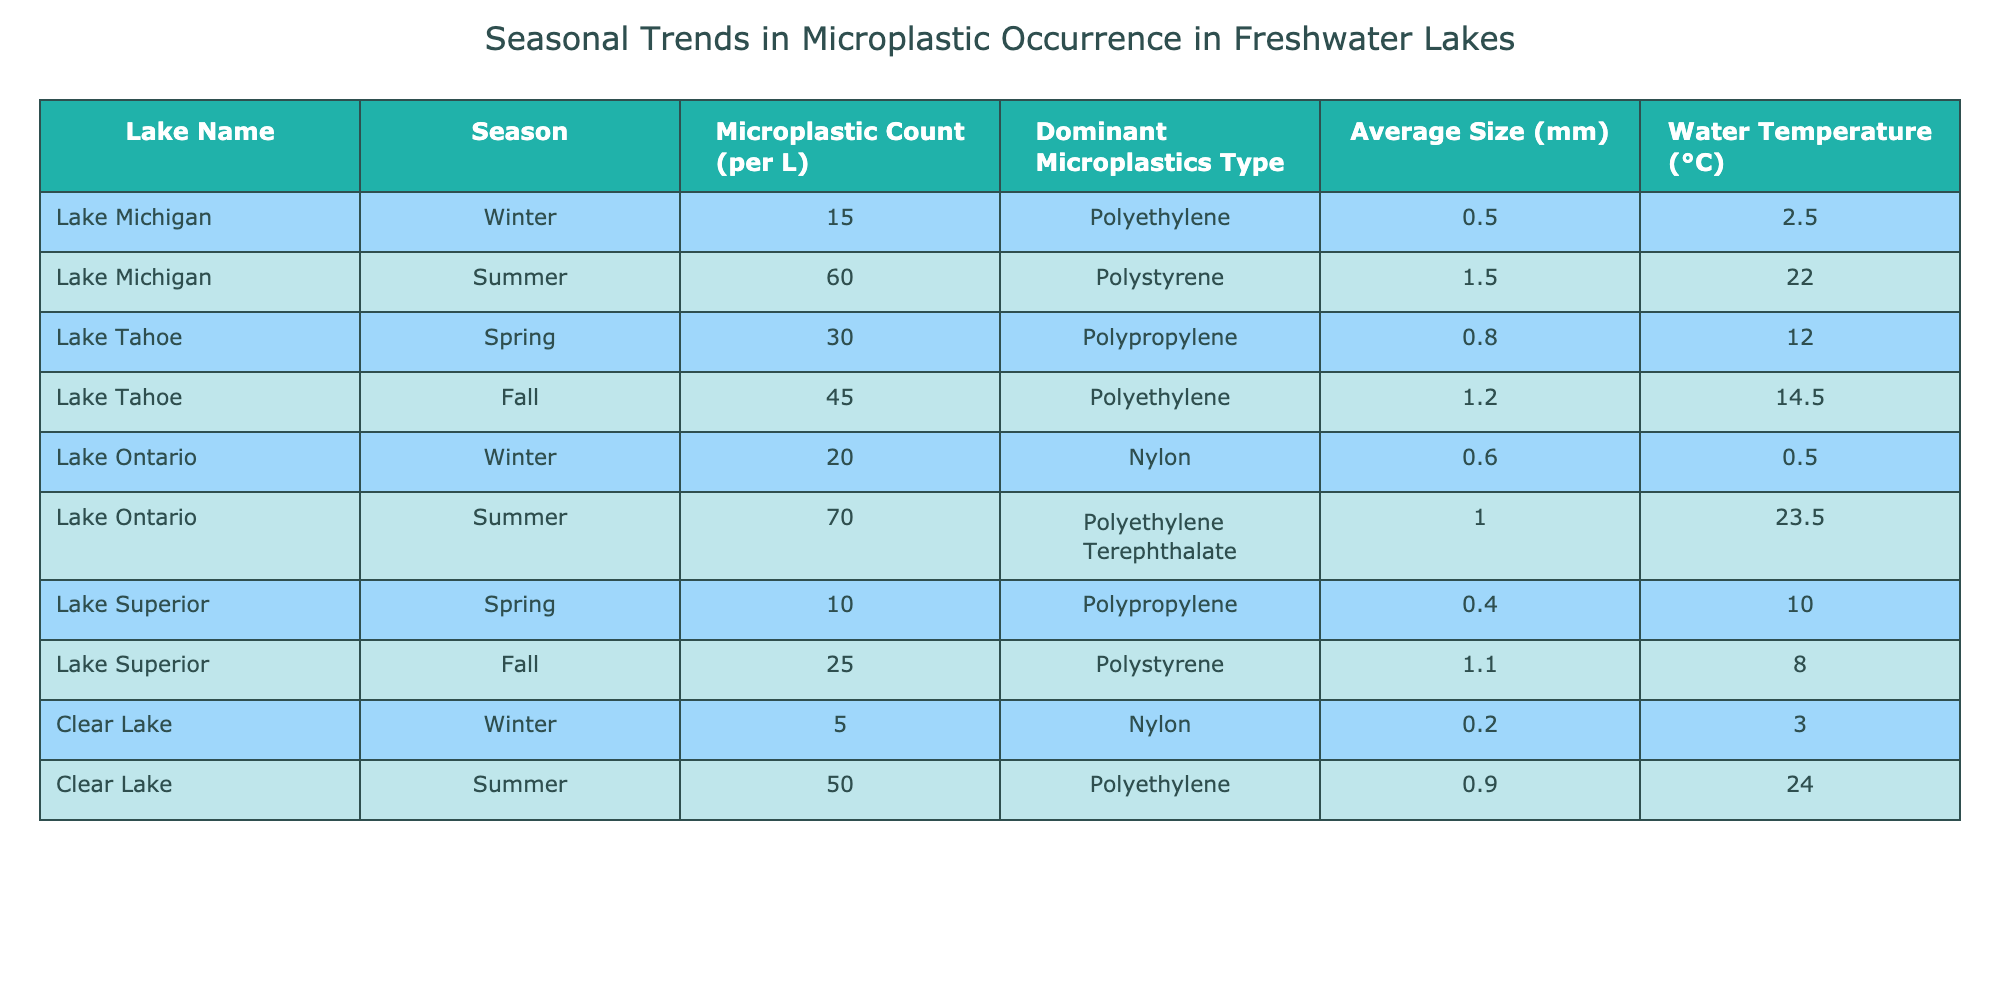What is the microplastic count in Lake Ontario during the summer? The table shows that in Lake Ontario during the summer, the microplastic count is 70.
Answer: 70 Which lake has the highest average water temperature, and what is that temperature? Looking at the table, Clear Lake has the highest average water temperature at 24.0°C during the summer.
Answer: Clear Lake, 24.0°C What is the total microplastic count for all lakes in the winter season? Summing the microplastic counts for all lakes in winter: Lake Michigan (15) + Lake Ontario (20) + Clear Lake (5) = 40.
Answer: 40 Is the dominant type of microplastic in Lake Tahoe during the fall polystyrene? The table indicates that the dominant type in Lake Tahoe during the fall is polyethylene, not polystyrene.
Answer: No Which lake shows a decrease in microplastic count from spring to fall? In Lake Superior, the microplastic count decreases from 10 in spring to 25 in fall, which is an increase instead. In Lake Tahoe, the count goes from 30 in spring to 45 in fall, which is also an increase. Therefore, no lake shows a decrease from spring to fall.
Answer: None What is the average size of microplastics for Lake Michigan across all seasons? In Lake Michigan, the average sizes are 0.5 mm in winter and 1.5 mm in summer. Calculating the average: (0.5 + 1.5) / 2 = 1.0 mm.
Answer: 1.0 mm How many lakes have a microplastic count of 50 or higher in the summer season? Looking at summer, Lake Michigan has 60, Lake Ontario has 70, and Clear Lake has 50. There are three lakes with counts of 50 or higher.
Answer: 3 Which season has the highest average microplastic count across all lakes listed? To calculate the average by season: Winter total is 40 (Lake Michigan 15 + Lake Ontario 20 + Clear Lake 5 = 40) with 3 entries gives 40/3 = 13.33. Summer total is 180 (Lake Michigan 60 + Lake Ontario 70 + Clear Lake 50 = 180) with 3 entries gives 180/3 = 60. Spring total is 40 (Lake Tahoe 30 + Lake Superior 10 = 40) with 2 entries gives 40/2 = 20. Fall total is 70 (Lake Tahoe 45 + Lake Superior 25 = 70) with 2 entries gives 70/2 = 35. The highest average is during summer at 60.
Answer: Summer, 60 